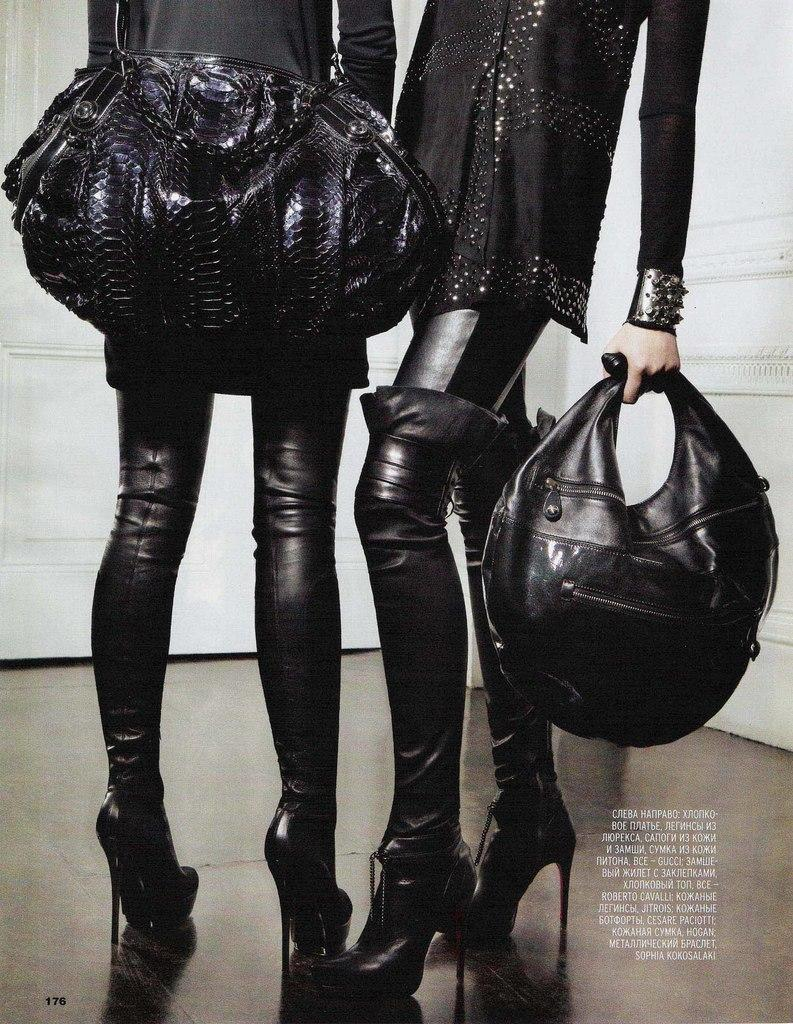How many women are in the image? There are two women in the image. What are the women wearing? Both women are wearing black dresses. What are the women holding in their hands? The women are holding black bags in their hands. What songs are the women singing in the image? There is no indication in the image that the women are singing songs, so it cannot be determined from the picture. 